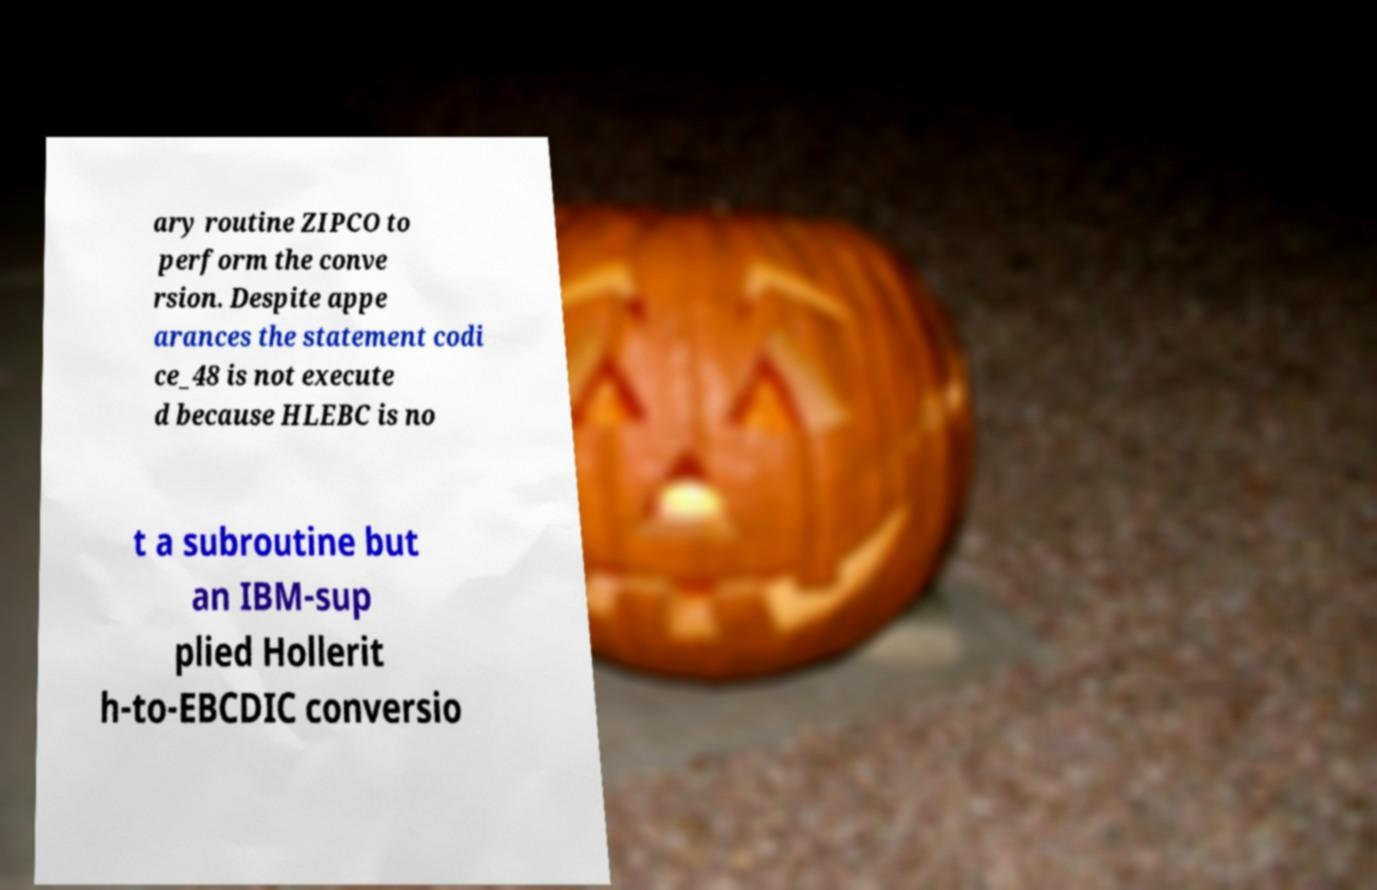For documentation purposes, I need the text within this image transcribed. Could you provide that? ary routine ZIPCO to perform the conve rsion. Despite appe arances the statement codi ce_48 is not execute d because HLEBC is no t a subroutine but an IBM-sup plied Hollerit h-to-EBCDIC conversio 